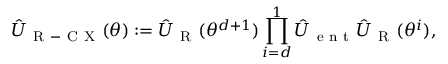<formula> <loc_0><loc_0><loc_500><loc_500>\hat { U } _ { R - C X } ( \theta ) \colon = \hat { U } _ { R } ( \theta ^ { d + 1 } ) \prod _ { i = d } ^ { 1 } \hat { U } _ { e n t } \hat { U } _ { R } ( \theta ^ { i } ) ,</formula> 